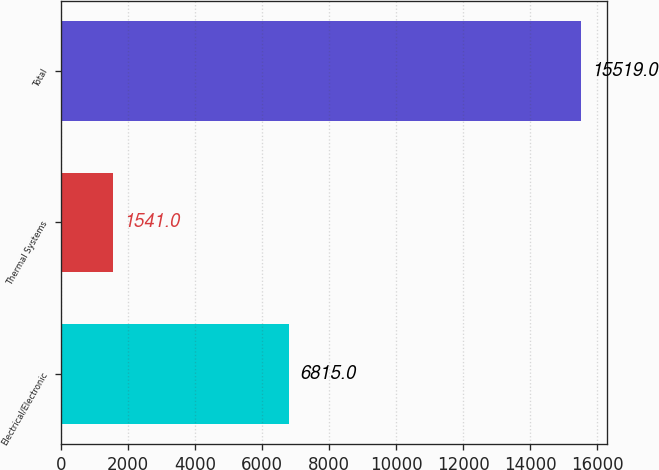Convert chart to OTSL. <chart><loc_0><loc_0><loc_500><loc_500><bar_chart><fcel>Electrical/Electronic<fcel>Thermal Systems<fcel>Total<nl><fcel>6815<fcel>1541<fcel>15519<nl></chart> 